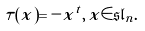<formula> <loc_0><loc_0><loc_500><loc_500>\tau ( x ) = - x ^ { t } , \, x \in \mathfrak { s l } _ { n } .</formula> 